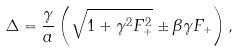<formula> <loc_0><loc_0><loc_500><loc_500>\Delta = \frac { \gamma } { a } \left ( \sqrt { 1 + \gamma ^ { 2 } F _ { + } ^ { 2 } } \pm \beta \gamma F _ { + } \right ) ,</formula> 